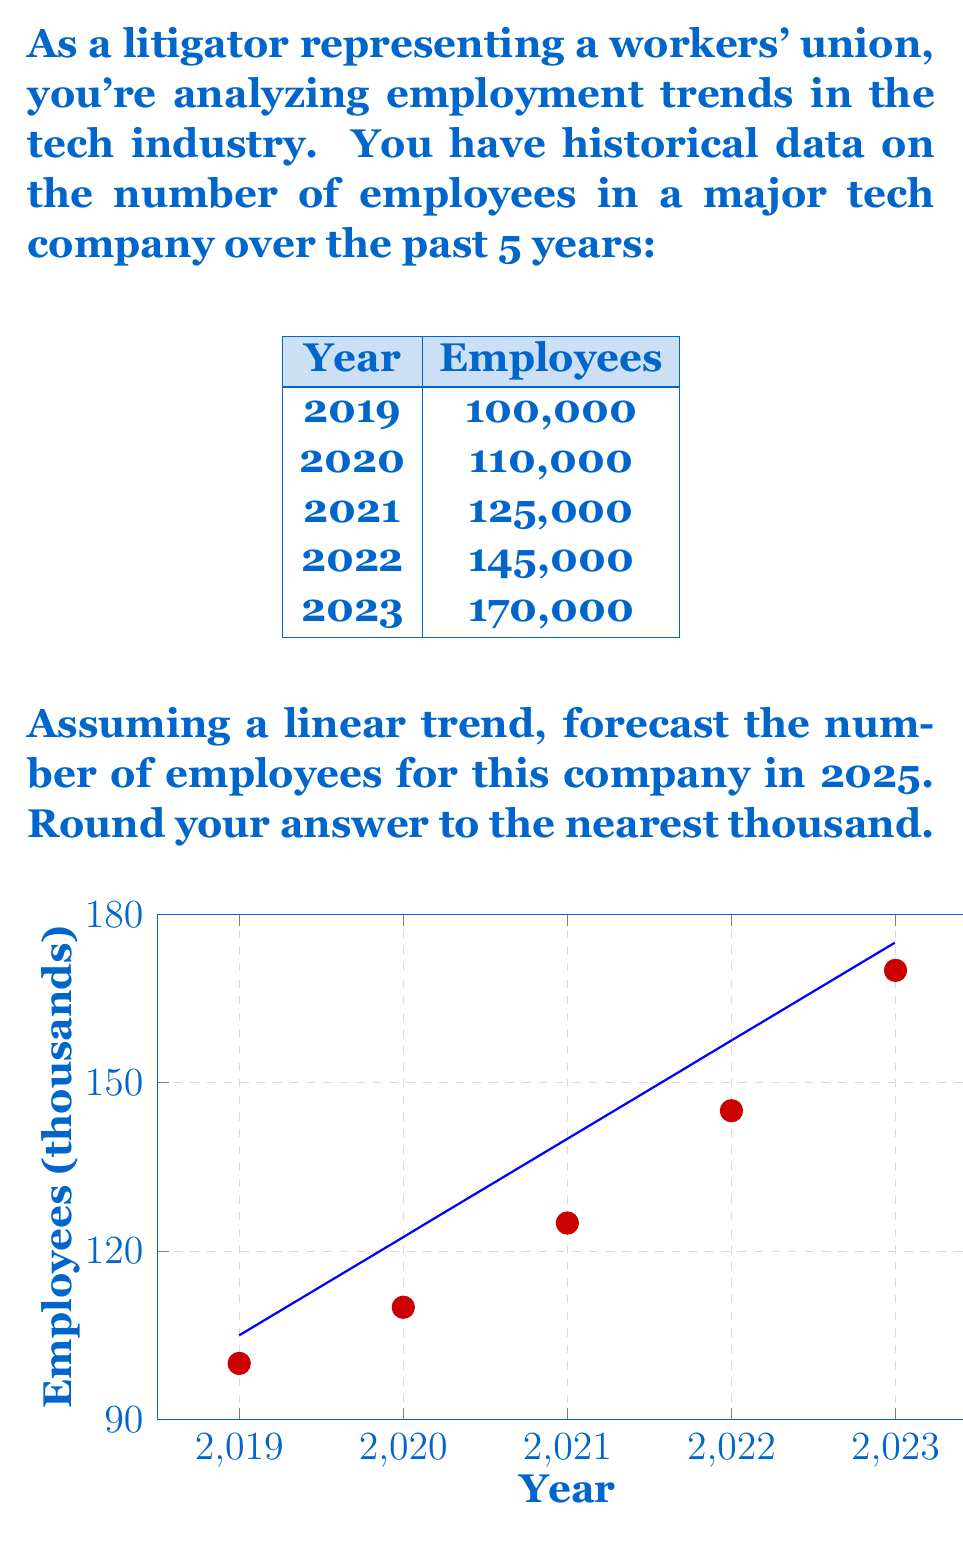Provide a solution to this math problem. To forecast the number of employees in 2025 using a linear trend, we'll follow these steps:

1) First, we need to find the slope (m) and y-intercept (b) of the linear trend line. We can use the least squares method, but for simplicity, we'll use the first and last data points:

   $m = \frac{y_2 - y_1}{x_2 - x_1} = \frac{170,000 - 100,000}{2023 - 2019} = 17,500$ employees per year

2) Now we can use the point-slope form of a line to find the y-intercept:

   $y - y_1 = m(x - x_1)$
   $170,000 - b = 17,500(2023 - 2019)$
   $170,000 - b = 70,000$
   $b = 100,000$

3) Our linear equation is:

   $y = 17,500x + 100,000$

   Where x is the number of years since 2019.

4) To forecast for 2025, we calculate:

   $y = 17,500(2025 - 2019) + 100,000$
   $y = 17,500(6) + 100,000$
   $y = 105,000 + 100,000$
   $y = 205,000$

5) Rounding to the nearest thousand:

   205,000 employees

This linear forecast suggests continued rapid growth, which could be a point of concern for the workers' union regarding potential workplace pressures and the need for fair labor practices.
Answer: 205,000 employees 